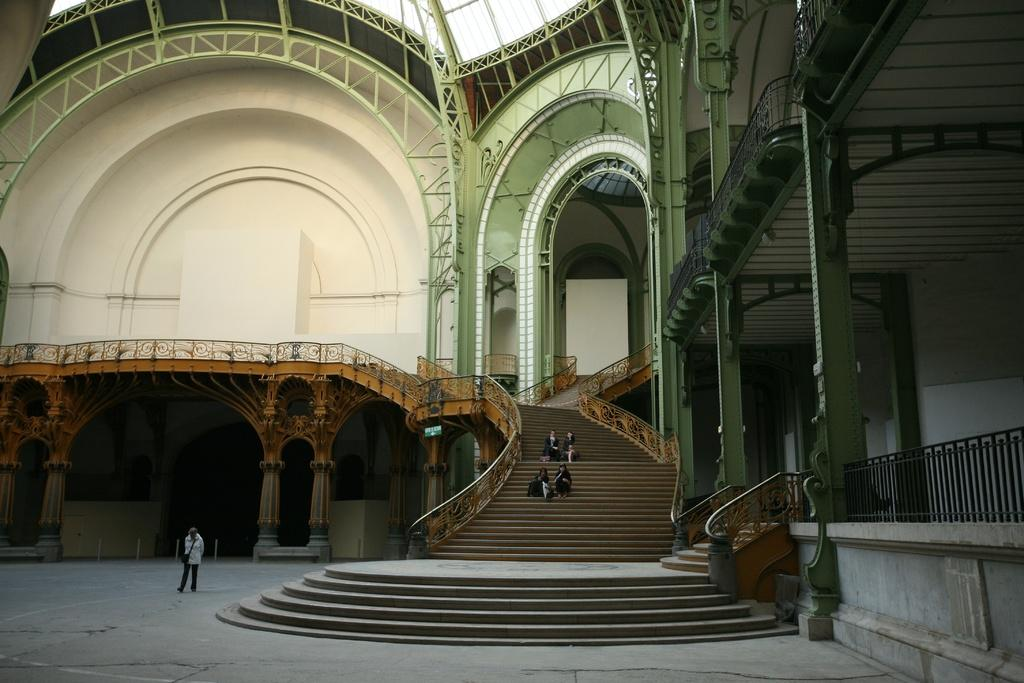What is the main subject of the image? There is a person walking in the image. What is the person walking on? The person is walking on the ground. What can be seen in the background of the image? There is a building and people sitting on steps in the background of the image. What type of stove is visible in the image? There is no stove present in the image. What scientific theory can be observed in action in the image? The image does not depict any scientific theory; it shows a person walking and a background with a building and people sitting on steps. 